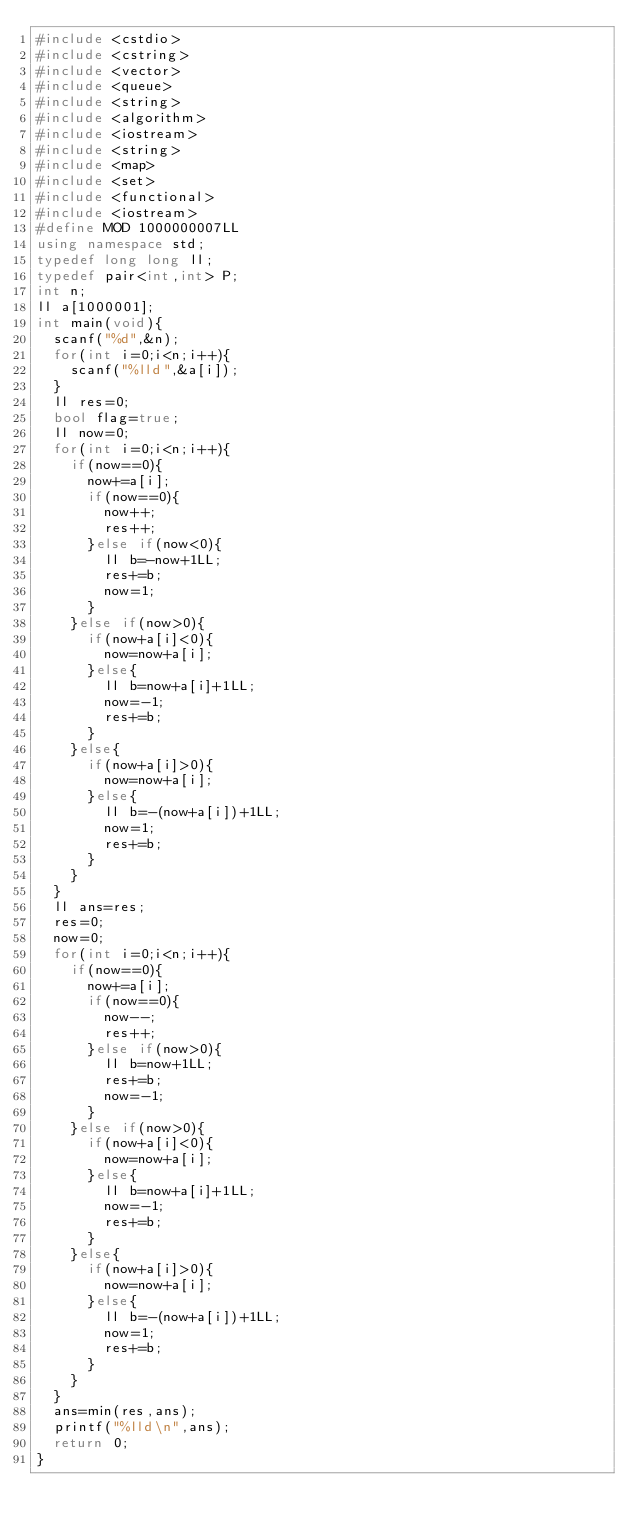Convert code to text. <code><loc_0><loc_0><loc_500><loc_500><_C++_>#include <cstdio>
#include <cstring>
#include <vector>
#include <queue>
#include <string>
#include <algorithm>
#include <iostream>
#include <string>
#include <map>
#include <set>
#include <functional>
#include <iostream>
#define MOD 1000000007LL
using namespace std;
typedef long long ll;
typedef pair<int,int> P;
int n;
ll a[1000001];
int main(void){
	scanf("%d",&n);
	for(int i=0;i<n;i++){
		scanf("%lld",&a[i]);
	}
	ll res=0;
	bool flag=true;
	ll now=0;
	for(int i=0;i<n;i++){
		if(now==0){
			now+=a[i];
			if(now==0){
				now++;
				res++;
			}else if(now<0){
				ll b=-now+1LL;
				res+=b;
				now=1;
			}
		}else if(now>0){
			if(now+a[i]<0){
				now=now+a[i];
			}else{
				ll b=now+a[i]+1LL;
				now=-1;
				res+=b;
			}
		}else{
			if(now+a[i]>0){
				now=now+a[i];
			}else{
				ll b=-(now+a[i])+1LL;
				now=1;
				res+=b;
			}
		}
	}
	ll ans=res;
	res=0;
	now=0;
	for(int i=0;i<n;i++){
		if(now==0){
			now+=a[i];
			if(now==0){
				now--;
				res++;
			}else if(now>0){
				ll b=now+1LL;
				res+=b;
				now=-1;
			}
		}else if(now>0){
			if(now+a[i]<0){
				now=now+a[i];
			}else{
				ll b=now+a[i]+1LL;
				now=-1;
				res+=b;
			}
		}else{
			if(now+a[i]>0){
				now=now+a[i];
			}else{
				ll b=-(now+a[i])+1LL;
				now=1;
				res+=b;
			}
		}
	}
	ans=min(res,ans);
	printf("%lld\n",ans);
	return 0;
}</code> 